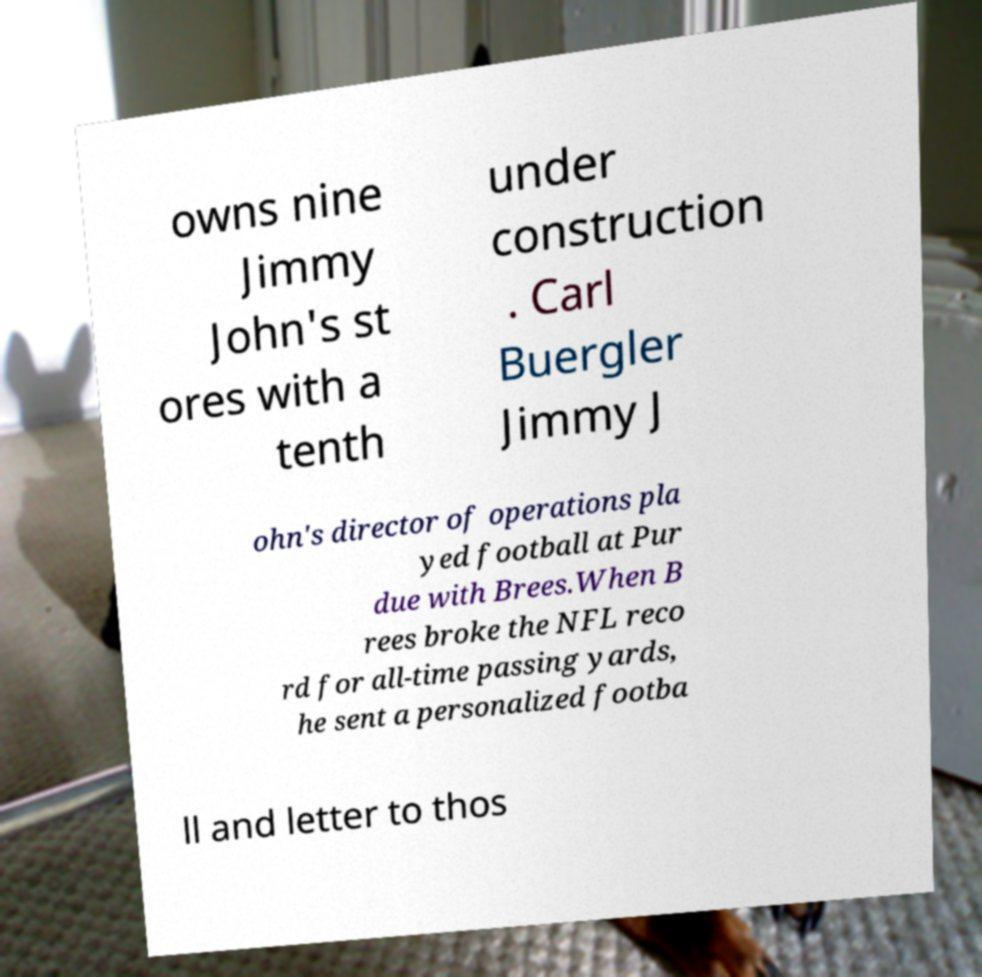Could you extract and type out the text from this image? owns nine Jimmy John's st ores with a tenth under construction . Carl Buergler Jimmy J ohn's director of operations pla yed football at Pur due with Brees.When B rees broke the NFL reco rd for all-time passing yards, he sent a personalized footba ll and letter to thos 